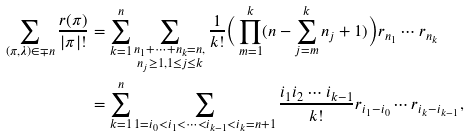<formula> <loc_0><loc_0><loc_500><loc_500>\sum _ { ( \pi , \lambda ) \in \mp n } \frac { r ( \pi ) } { | \pi | ! } & = \sum _ { k = 1 } ^ { n } \sum _ { \substack { n _ { 1 } + \cdots + n _ { k } = n , \\ n _ { j } \geq 1 , 1 \leq j \leq k } } \frac { 1 } { k ! } \Big { ( } \prod _ { m = 1 } ^ { k } ( n - \sum _ { j = m } ^ { k } n _ { j } + 1 ) \Big { ) } r _ { n _ { 1 } } \cdots r _ { n _ { k } } \\ & = \sum _ { k = 1 } ^ { n } \sum _ { 1 = i _ { 0 } < i _ { 1 } < \cdots < i _ { k - 1 } < i _ { k } = n + 1 } \frac { i _ { 1 } i _ { 2 } \cdots i _ { k - 1 } } { k ! } r _ { i _ { 1 } - i _ { 0 } } \cdots r _ { i _ { k } - i _ { k - 1 } } ,</formula> 